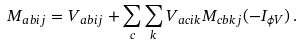Convert formula to latex. <formula><loc_0><loc_0><loc_500><loc_500>M _ { a b i j } = V _ { a b i j } + \sum _ { c } \sum _ { k } V _ { a c i k } M _ { c b k j } ( - I _ { \phi V } ) \, .</formula> 